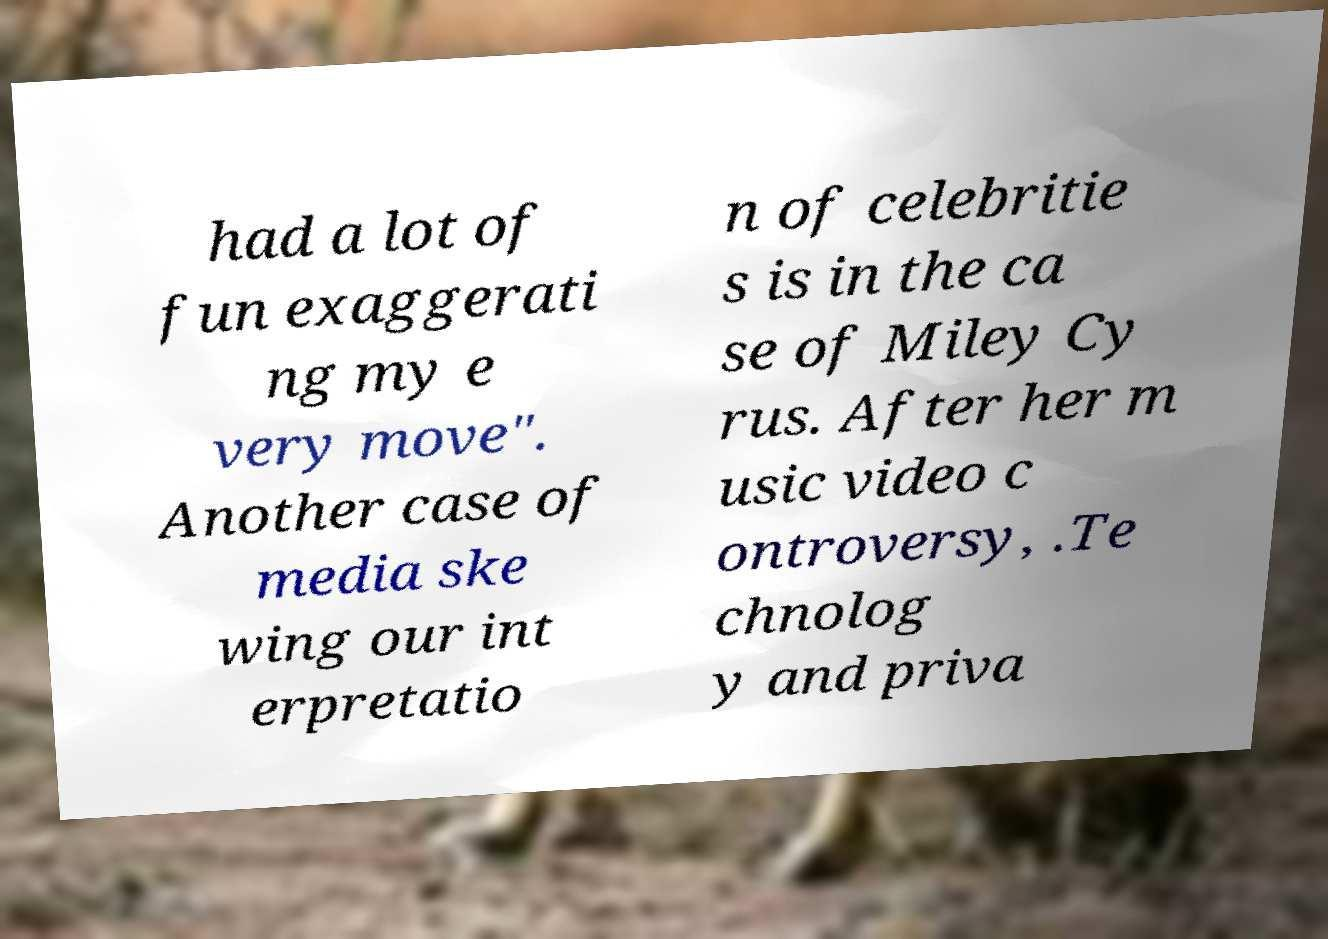Please identify and transcribe the text found in this image. had a lot of fun exaggerati ng my e very move". Another case of media ske wing our int erpretatio n of celebritie s is in the ca se of Miley Cy rus. After her m usic video c ontroversy, .Te chnolog y and priva 